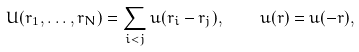<formula> <loc_0><loc_0><loc_500><loc_500>U ( { r } _ { 1 } , \dots , { r } _ { N } ) = \sum _ { i < j } u ( { r } _ { i } - { r } _ { j } ) , \quad u ( { r } ) = u ( - { r } ) ,</formula> 